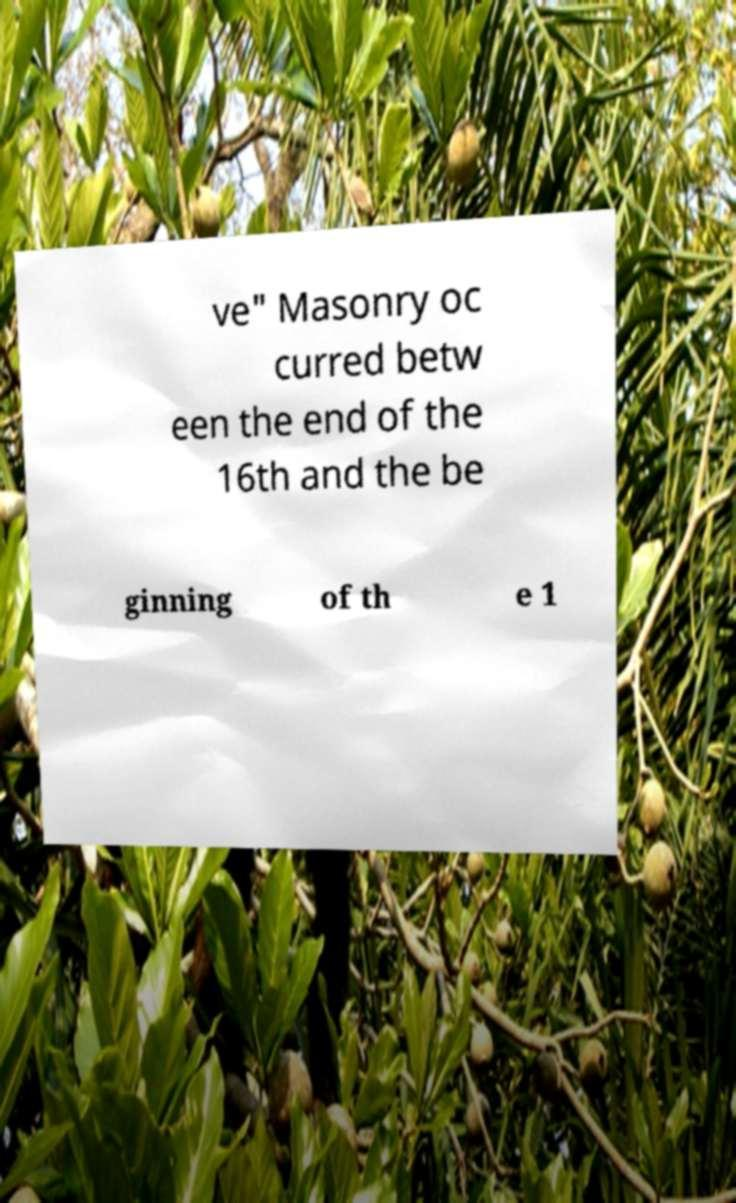For documentation purposes, I need the text within this image transcribed. Could you provide that? ve" Masonry oc curred betw een the end of the 16th and the be ginning of th e 1 